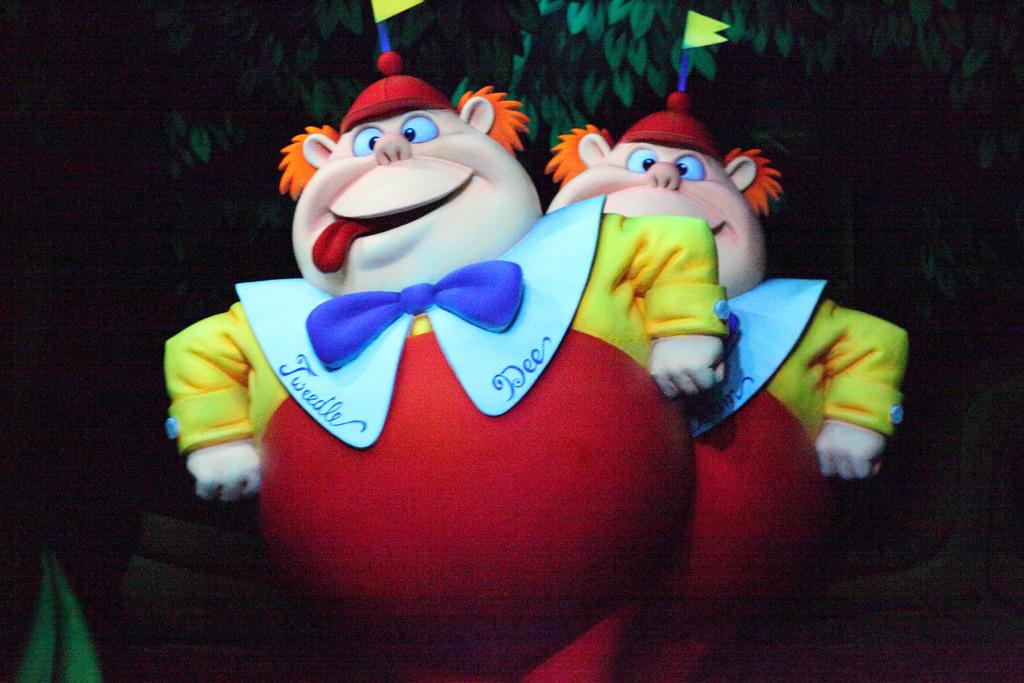What objects can be seen in the front of the image? There are two toys in the front of the image. What type of natural elements can be seen in the background of the image? Leaves are visible in the background of the image. How would you describe the lighting in the image? The background of the image is dark. What type of drink is being served in the pail in the image? There is no pail or drink present in the image. 